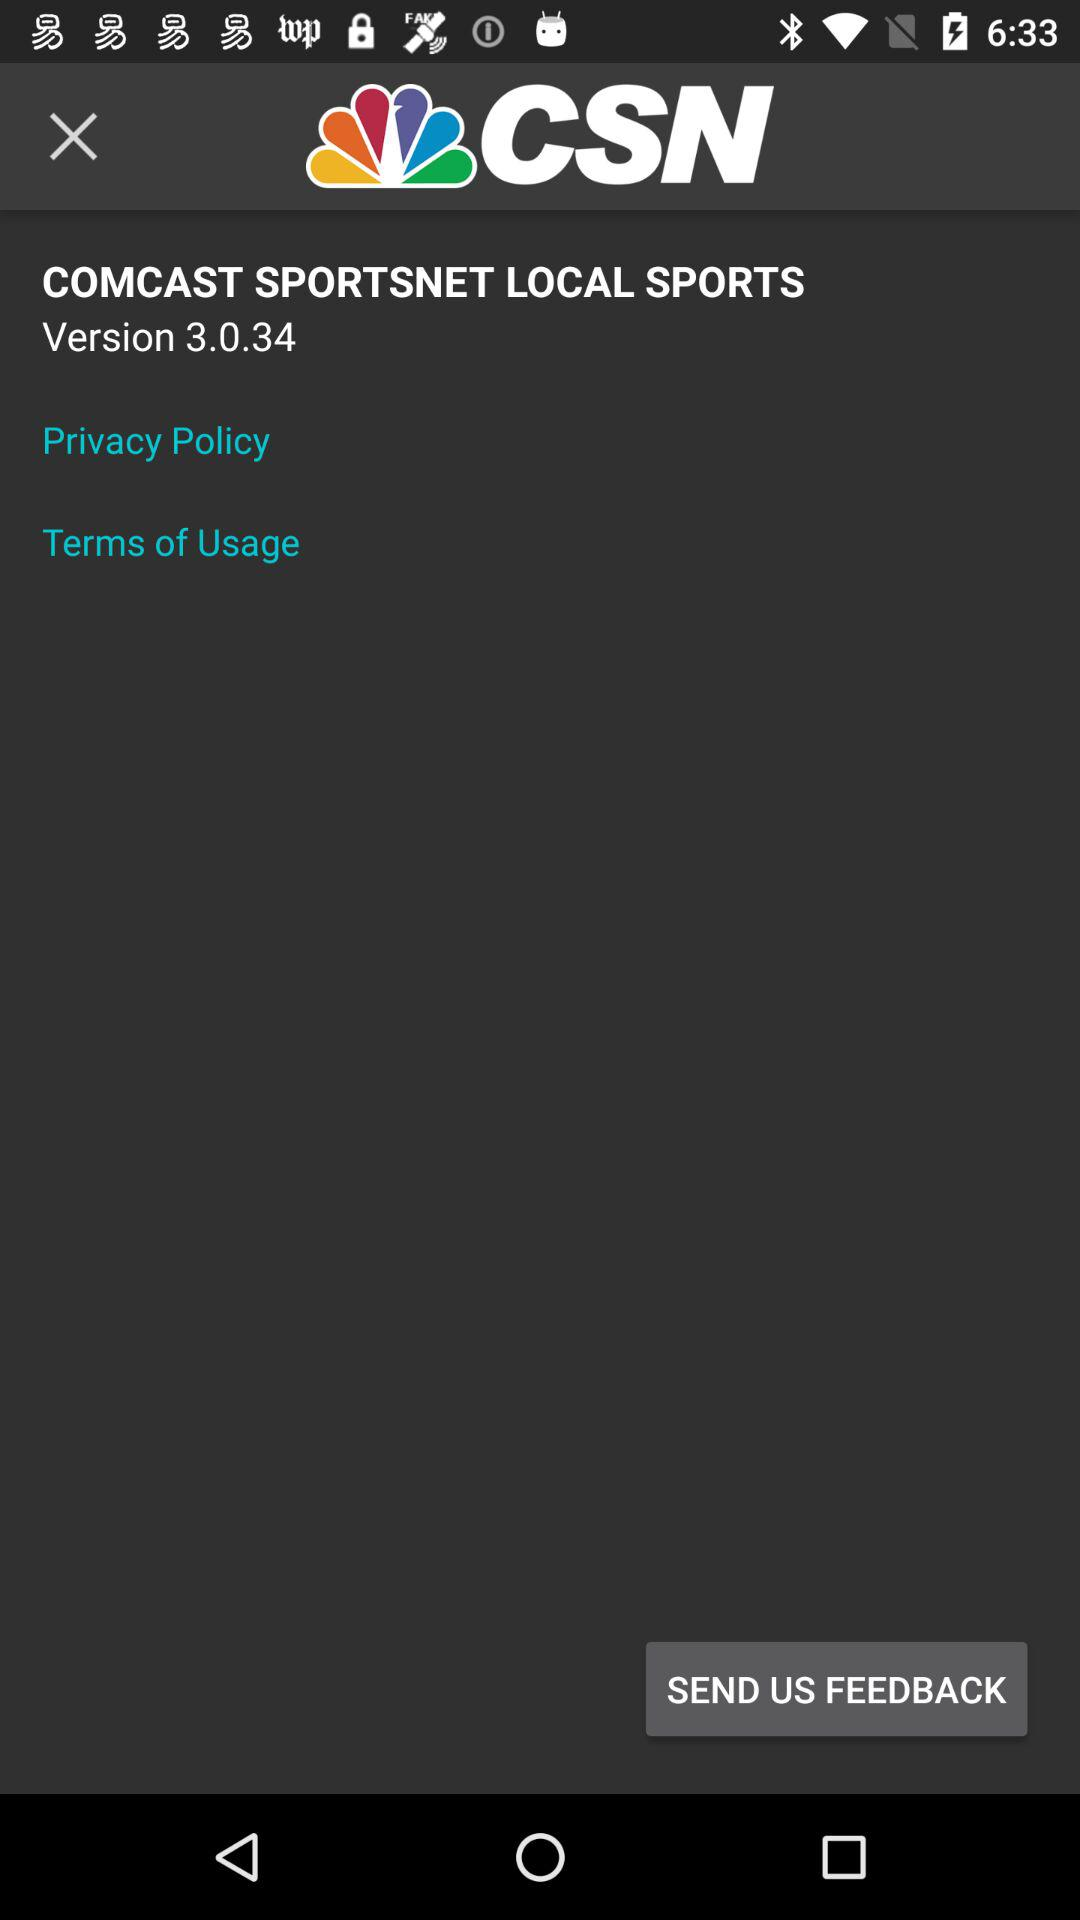What is the used version? The used version is 3.0.34. 